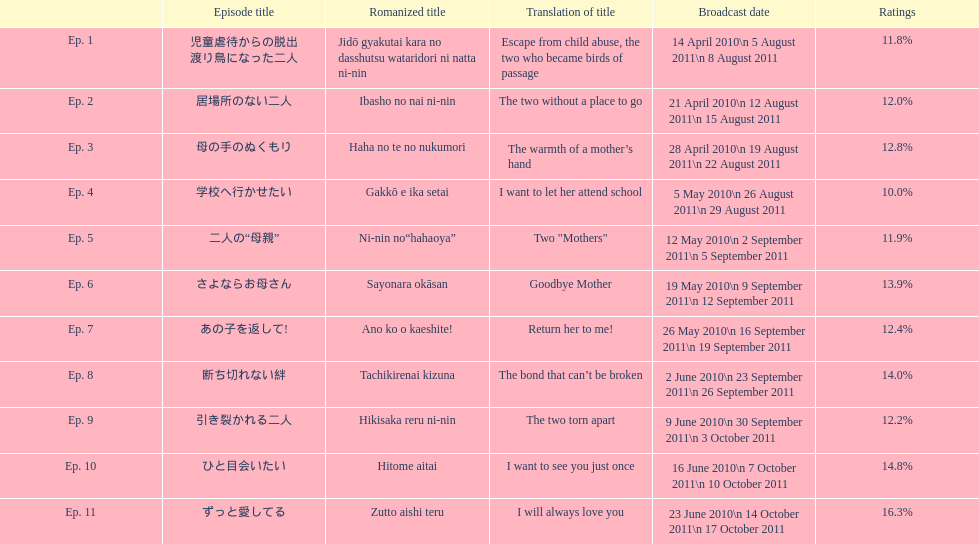How many episodes are below 14%? 8. 